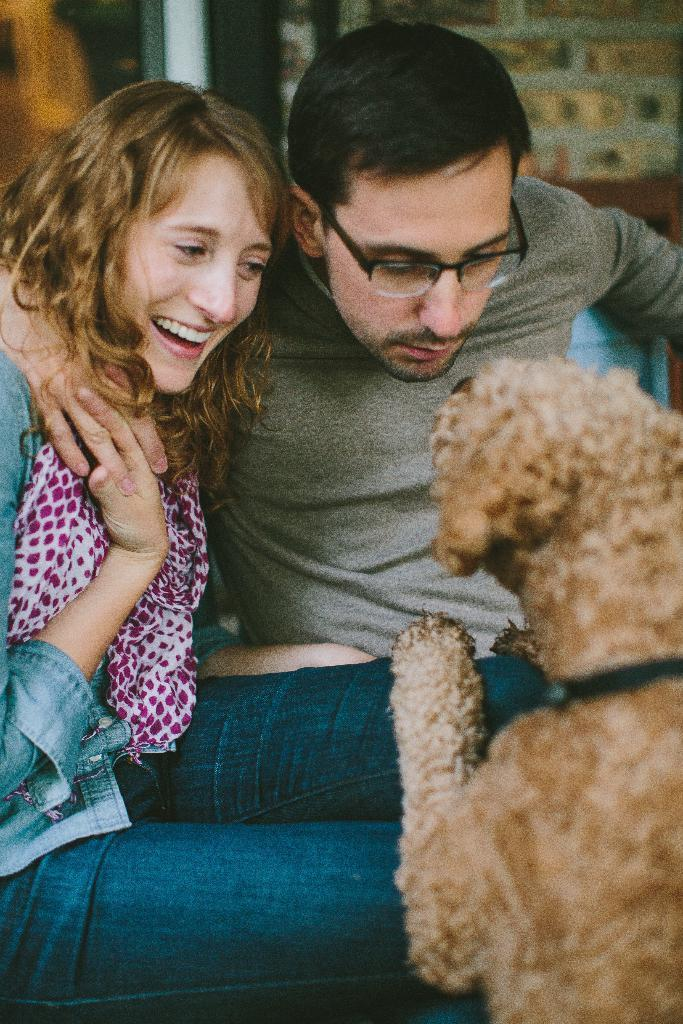What type of animal is on the right side of the image? There is a dog on the right side of the image. What are the two persons doing on the left side of the image? The two persons are sitting on the left side of the image. What else can be seen in the background of the image? There are other objects visible in the background of the image. What type of beast is visible in the image? There is no beast present in the image; it features a dog, which is a domesticated animal and not considered a beast. What is the dog using to carry water in the image? There is no pail or any other object used for carrying water visible in the image. 